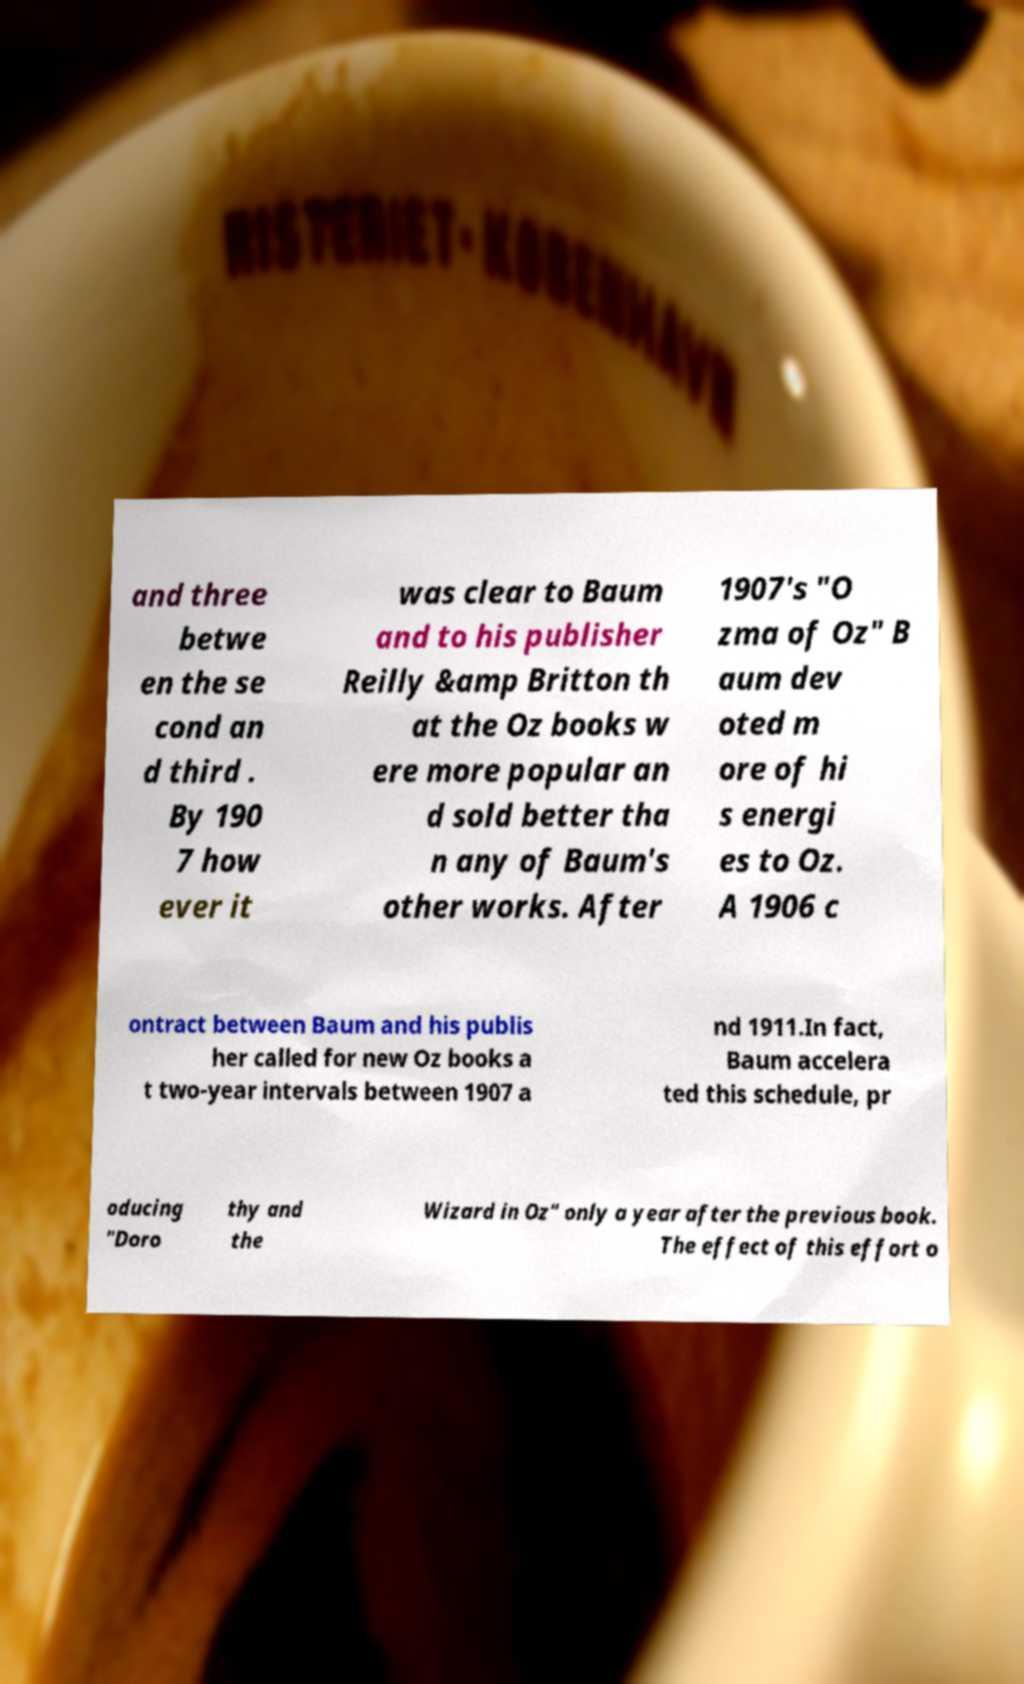I need the written content from this picture converted into text. Can you do that? and three betwe en the se cond an d third . By 190 7 how ever it was clear to Baum and to his publisher Reilly &amp Britton th at the Oz books w ere more popular an d sold better tha n any of Baum's other works. After 1907's "O zma of Oz" B aum dev oted m ore of hi s energi es to Oz. A 1906 c ontract between Baum and his publis her called for new Oz books a t two-year intervals between 1907 a nd 1911.In fact, Baum accelera ted this schedule, pr oducing "Doro thy and the Wizard in Oz" only a year after the previous book. The effect of this effort o 